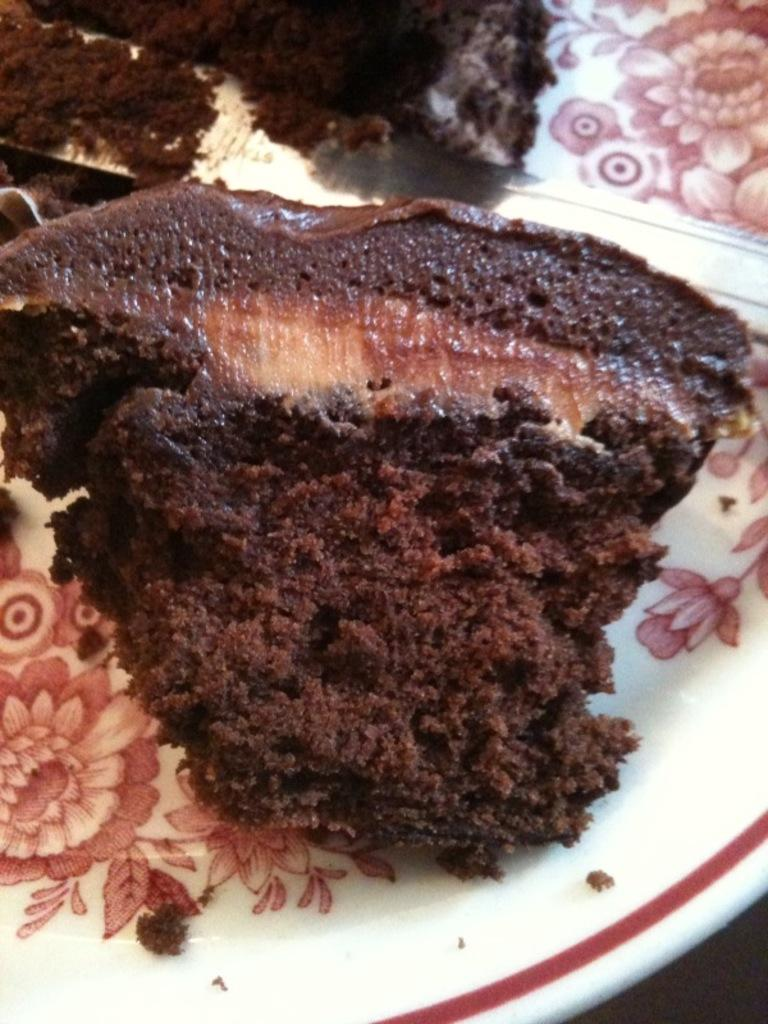What object is present on the plate in the image? There is a food item on the plate in the image. What can be used to cut the food item on the plate? There is a knife in the image that can be used to cut the food item. What type of music is playing in the background of the image? There is no music or background noise mentioned in the image, so it cannot be determined. 